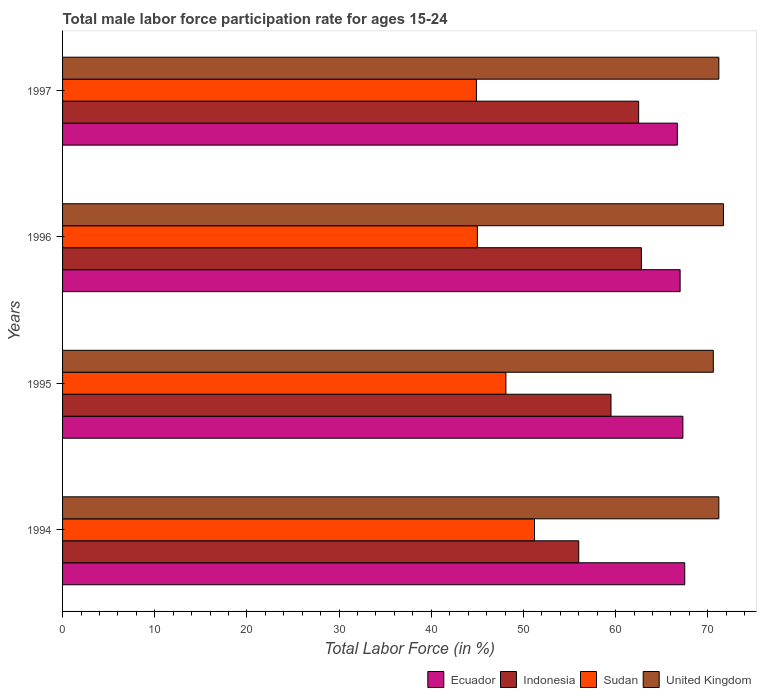Are the number of bars per tick equal to the number of legend labels?
Give a very brief answer. Yes. Are the number of bars on each tick of the Y-axis equal?
Your response must be concise. Yes. What is the male labor force participation rate in United Kingdom in 1994?
Provide a short and direct response. 71.2. Across all years, what is the maximum male labor force participation rate in Ecuador?
Ensure brevity in your answer.  67.5. Across all years, what is the minimum male labor force participation rate in Sudan?
Ensure brevity in your answer.  44.9. What is the total male labor force participation rate in United Kingdom in the graph?
Ensure brevity in your answer.  284.7. What is the difference between the male labor force participation rate in United Kingdom in 1995 and that in 1997?
Make the answer very short. -0.6. What is the difference between the male labor force participation rate in Indonesia in 1994 and the male labor force participation rate in Sudan in 1995?
Offer a very short reply. 7.9. What is the average male labor force participation rate in Sudan per year?
Offer a very short reply. 47.3. In the year 1994, what is the difference between the male labor force participation rate in United Kingdom and male labor force participation rate in Sudan?
Make the answer very short. 20. What is the ratio of the male labor force participation rate in Indonesia in 1994 to that in 1997?
Your answer should be very brief. 0.9. Is the male labor force participation rate in Ecuador in 1995 less than that in 1996?
Provide a short and direct response. No. What is the difference between the highest and the second highest male labor force participation rate in Indonesia?
Offer a terse response. 0.3. What is the difference between the highest and the lowest male labor force participation rate in Ecuador?
Keep it short and to the point. 0.8. Is it the case that in every year, the sum of the male labor force participation rate in United Kingdom and male labor force participation rate in Ecuador is greater than the sum of male labor force participation rate in Sudan and male labor force participation rate in Indonesia?
Offer a very short reply. Yes. What does the 3rd bar from the top in 1997 represents?
Provide a short and direct response. Indonesia. What does the 1st bar from the bottom in 1996 represents?
Your answer should be compact. Ecuador. How many bars are there?
Your answer should be very brief. 16. Are the values on the major ticks of X-axis written in scientific E-notation?
Give a very brief answer. No. Does the graph contain any zero values?
Keep it short and to the point. No. Where does the legend appear in the graph?
Provide a short and direct response. Bottom right. How many legend labels are there?
Your answer should be very brief. 4. What is the title of the graph?
Make the answer very short. Total male labor force participation rate for ages 15-24. What is the label or title of the X-axis?
Offer a terse response. Total Labor Force (in %). What is the label or title of the Y-axis?
Ensure brevity in your answer.  Years. What is the Total Labor Force (in %) in Ecuador in 1994?
Give a very brief answer. 67.5. What is the Total Labor Force (in %) in Indonesia in 1994?
Your response must be concise. 56. What is the Total Labor Force (in %) in Sudan in 1994?
Give a very brief answer. 51.2. What is the Total Labor Force (in %) in United Kingdom in 1994?
Offer a terse response. 71.2. What is the Total Labor Force (in %) in Ecuador in 1995?
Offer a very short reply. 67.3. What is the Total Labor Force (in %) of Indonesia in 1995?
Ensure brevity in your answer.  59.5. What is the Total Labor Force (in %) in Sudan in 1995?
Your answer should be compact. 48.1. What is the Total Labor Force (in %) in United Kingdom in 1995?
Keep it short and to the point. 70.6. What is the Total Labor Force (in %) of Indonesia in 1996?
Your response must be concise. 62.8. What is the Total Labor Force (in %) of Sudan in 1996?
Your answer should be compact. 45. What is the Total Labor Force (in %) of United Kingdom in 1996?
Your answer should be very brief. 71.7. What is the Total Labor Force (in %) in Ecuador in 1997?
Make the answer very short. 66.7. What is the Total Labor Force (in %) of Indonesia in 1997?
Make the answer very short. 62.5. What is the Total Labor Force (in %) in Sudan in 1997?
Offer a terse response. 44.9. What is the Total Labor Force (in %) of United Kingdom in 1997?
Provide a succinct answer. 71.2. Across all years, what is the maximum Total Labor Force (in %) of Ecuador?
Offer a terse response. 67.5. Across all years, what is the maximum Total Labor Force (in %) in Indonesia?
Ensure brevity in your answer.  62.8. Across all years, what is the maximum Total Labor Force (in %) in Sudan?
Keep it short and to the point. 51.2. Across all years, what is the maximum Total Labor Force (in %) in United Kingdom?
Provide a succinct answer. 71.7. Across all years, what is the minimum Total Labor Force (in %) of Ecuador?
Give a very brief answer. 66.7. Across all years, what is the minimum Total Labor Force (in %) of Indonesia?
Your response must be concise. 56. Across all years, what is the minimum Total Labor Force (in %) in Sudan?
Provide a succinct answer. 44.9. Across all years, what is the minimum Total Labor Force (in %) of United Kingdom?
Your answer should be compact. 70.6. What is the total Total Labor Force (in %) of Ecuador in the graph?
Your answer should be very brief. 268.5. What is the total Total Labor Force (in %) of Indonesia in the graph?
Give a very brief answer. 240.8. What is the total Total Labor Force (in %) in Sudan in the graph?
Give a very brief answer. 189.2. What is the total Total Labor Force (in %) of United Kingdom in the graph?
Your answer should be compact. 284.7. What is the difference between the Total Labor Force (in %) of Ecuador in 1994 and that in 1995?
Keep it short and to the point. 0.2. What is the difference between the Total Labor Force (in %) in United Kingdom in 1994 and that in 1995?
Your answer should be very brief. 0.6. What is the difference between the Total Labor Force (in %) in Ecuador in 1994 and that in 1996?
Keep it short and to the point. 0.5. What is the difference between the Total Labor Force (in %) in Ecuador in 1994 and that in 1997?
Your answer should be very brief. 0.8. What is the difference between the Total Labor Force (in %) of United Kingdom in 1994 and that in 1997?
Give a very brief answer. 0. What is the difference between the Total Labor Force (in %) of United Kingdom in 1995 and that in 1996?
Give a very brief answer. -1.1. What is the difference between the Total Labor Force (in %) in Sudan in 1995 and that in 1997?
Your answer should be very brief. 3.2. What is the difference between the Total Labor Force (in %) in United Kingdom in 1995 and that in 1997?
Provide a succinct answer. -0.6. What is the difference between the Total Labor Force (in %) in Ecuador in 1996 and that in 1997?
Provide a short and direct response. 0.3. What is the difference between the Total Labor Force (in %) of Indonesia in 1996 and that in 1997?
Ensure brevity in your answer.  0.3. What is the difference between the Total Labor Force (in %) in Sudan in 1996 and that in 1997?
Provide a short and direct response. 0.1. What is the difference between the Total Labor Force (in %) in United Kingdom in 1996 and that in 1997?
Provide a succinct answer. 0.5. What is the difference between the Total Labor Force (in %) in Ecuador in 1994 and the Total Labor Force (in %) in Indonesia in 1995?
Provide a succinct answer. 8. What is the difference between the Total Labor Force (in %) of Indonesia in 1994 and the Total Labor Force (in %) of United Kingdom in 1995?
Ensure brevity in your answer.  -14.6. What is the difference between the Total Labor Force (in %) in Sudan in 1994 and the Total Labor Force (in %) in United Kingdom in 1995?
Ensure brevity in your answer.  -19.4. What is the difference between the Total Labor Force (in %) of Ecuador in 1994 and the Total Labor Force (in %) of Indonesia in 1996?
Provide a short and direct response. 4.7. What is the difference between the Total Labor Force (in %) in Ecuador in 1994 and the Total Labor Force (in %) in Sudan in 1996?
Keep it short and to the point. 22.5. What is the difference between the Total Labor Force (in %) in Indonesia in 1994 and the Total Labor Force (in %) in United Kingdom in 1996?
Ensure brevity in your answer.  -15.7. What is the difference between the Total Labor Force (in %) in Sudan in 1994 and the Total Labor Force (in %) in United Kingdom in 1996?
Make the answer very short. -20.5. What is the difference between the Total Labor Force (in %) in Ecuador in 1994 and the Total Labor Force (in %) in Indonesia in 1997?
Offer a very short reply. 5. What is the difference between the Total Labor Force (in %) of Ecuador in 1994 and the Total Labor Force (in %) of Sudan in 1997?
Ensure brevity in your answer.  22.6. What is the difference between the Total Labor Force (in %) in Ecuador in 1994 and the Total Labor Force (in %) in United Kingdom in 1997?
Your answer should be compact. -3.7. What is the difference between the Total Labor Force (in %) of Indonesia in 1994 and the Total Labor Force (in %) of United Kingdom in 1997?
Your answer should be very brief. -15.2. What is the difference between the Total Labor Force (in %) of Ecuador in 1995 and the Total Labor Force (in %) of Indonesia in 1996?
Your answer should be compact. 4.5. What is the difference between the Total Labor Force (in %) in Ecuador in 1995 and the Total Labor Force (in %) in Sudan in 1996?
Provide a succinct answer. 22.3. What is the difference between the Total Labor Force (in %) in Ecuador in 1995 and the Total Labor Force (in %) in United Kingdom in 1996?
Give a very brief answer. -4.4. What is the difference between the Total Labor Force (in %) in Indonesia in 1995 and the Total Labor Force (in %) in Sudan in 1996?
Your response must be concise. 14.5. What is the difference between the Total Labor Force (in %) in Indonesia in 1995 and the Total Labor Force (in %) in United Kingdom in 1996?
Your response must be concise. -12.2. What is the difference between the Total Labor Force (in %) of Sudan in 1995 and the Total Labor Force (in %) of United Kingdom in 1996?
Offer a very short reply. -23.6. What is the difference between the Total Labor Force (in %) in Ecuador in 1995 and the Total Labor Force (in %) in Indonesia in 1997?
Provide a succinct answer. 4.8. What is the difference between the Total Labor Force (in %) of Ecuador in 1995 and the Total Labor Force (in %) of Sudan in 1997?
Your answer should be very brief. 22.4. What is the difference between the Total Labor Force (in %) in Ecuador in 1995 and the Total Labor Force (in %) in United Kingdom in 1997?
Give a very brief answer. -3.9. What is the difference between the Total Labor Force (in %) of Indonesia in 1995 and the Total Labor Force (in %) of Sudan in 1997?
Make the answer very short. 14.6. What is the difference between the Total Labor Force (in %) in Indonesia in 1995 and the Total Labor Force (in %) in United Kingdom in 1997?
Your answer should be compact. -11.7. What is the difference between the Total Labor Force (in %) in Sudan in 1995 and the Total Labor Force (in %) in United Kingdom in 1997?
Provide a succinct answer. -23.1. What is the difference between the Total Labor Force (in %) in Ecuador in 1996 and the Total Labor Force (in %) in Indonesia in 1997?
Provide a succinct answer. 4.5. What is the difference between the Total Labor Force (in %) in Ecuador in 1996 and the Total Labor Force (in %) in Sudan in 1997?
Make the answer very short. 22.1. What is the difference between the Total Labor Force (in %) of Indonesia in 1996 and the Total Labor Force (in %) of Sudan in 1997?
Your response must be concise. 17.9. What is the difference between the Total Labor Force (in %) of Sudan in 1996 and the Total Labor Force (in %) of United Kingdom in 1997?
Offer a very short reply. -26.2. What is the average Total Labor Force (in %) of Ecuador per year?
Ensure brevity in your answer.  67.12. What is the average Total Labor Force (in %) of Indonesia per year?
Your answer should be very brief. 60.2. What is the average Total Labor Force (in %) in Sudan per year?
Provide a succinct answer. 47.3. What is the average Total Labor Force (in %) in United Kingdom per year?
Give a very brief answer. 71.17. In the year 1994, what is the difference between the Total Labor Force (in %) in Ecuador and Total Labor Force (in %) in Sudan?
Provide a succinct answer. 16.3. In the year 1994, what is the difference between the Total Labor Force (in %) in Indonesia and Total Labor Force (in %) in Sudan?
Your answer should be very brief. 4.8. In the year 1994, what is the difference between the Total Labor Force (in %) in Indonesia and Total Labor Force (in %) in United Kingdom?
Provide a short and direct response. -15.2. In the year 1995, what is the difference between the Total Labor Force (in %) of Ecuador and Total Labor Force (in %) of Indonesia?
Your answer should be very brief. 7.8. In the year 1995, what is the difference between the Total Labor Force (in %) of Indonesia and Total Labor Force (in %) of Sudan?
Your answer should be very brief. 11.4. In the year 1995, what is the difference between the Total Labor Force (in %) of Sudan and Total Labor Force (in %) of United Kingdom?
Give a very brief answer. -22.5. In the year 1996, what is the difference between the Total Labor Force (in %) of Ecuador and Total Labor Force (in %) of Indonesia?
Your answer should be very brief. 4.2. In the year 1996, what is the difference between the Total Labor Force (in %) in Indonesia and Total Labor Force (in %) in Sudan?
Offer a very short reply. 17.8. In the year 1996, what is the difference between the Total Labor Force (in %) in Sudan and Total Labor Force (in %) in United Kingdom?
Offer a terse response. -26.7. In the year 1997, what is the difference between the Total Labor Force (in %) in Ecuador and Total Labor Force (in %) in Sudan?
Provide a short and direct response. 21.8. In the year 1997, what is the difference between the Total Labor Force (in %) of Ecuador and Total Labor Force (in %) of United Kingdom?
Your answer should be compact. -4.5. In the year 1997, what is the difference between the Total Labor Force (in %) in Indonesia and Total Labor Force (in %) in United Kingdom?
Make the answer very short. -8.7. In the year 1997, what is the difference between the Total Labor Force (in %) in Sudan and Total Labor Force (in %) in United Kingdom?
Your response must be concise. -26.3. What is the ratio of the Total Labor Force (in %) in Sudan in 1994 to that in 1995?
Keep it short and to the point. 1.06. What is the ratio of the Total Labor Force (in %) in United Kingdom in 1994 to that in 1995?
Provide a succinct answer. 1.01. What is the ratio of the Total Labor Force (in %) of Ecuador in 1994 to that in 1996?
Offer a terse response. 1.01. What is the ratio of the Total Labor Force (in %) in Indonesia in 1994 to that in 1996?
Give a very brief answer. 0.89. What is the ratio of the Total Labor Force (in %) of Sudan in 1994 to that in 1996?
Provide a short and direct response. 1.14. What is the ratio of the Total Labor Force (in %) of United Kingdom in 1994 to that in 1996?
Your answer should be very brief. 0.99. What is the ratio of the Total Labor Force (in %) of Ecuador in 1994 to that in 1997?
Offer a very short reply. 1.01. What is the ratio of the Total Labor Force (in %) of Indonesia in 1994 to that in 1997?
Give a very brief answer. 0.9. What is the ratio of the Total Labor Force (in %) in Sudan in 1994 to that in 1997?
Make the answer very short. 1.14. What is the ratio of the Total Labor Force (in %) in United Kingdom in 1994 to that in 1997?
Keep it short and to the point. 1. What is the ratio of the Total Labor Force (in %) in Indonesia in 1995 to that in 1996?
Give a very brief answer. 0.95. What is the ratio of the Total Labor Force (in %) of Sudan in 1995 to that in 1996?
Ensure brevity in your answer.  1.07. What is the ratio of the Total Labor Force (in %) in United Kingdom in 1995 to that in 1996?
Ensure brevity in your answer.  0.98. What is the ratio of the Total Labor Force (in %) of Sudan in 1995 to that in 1997?
Your response must be concise. 1.07. What is the ratio of the Total Labor Force (in %) in United Kingdom in 1995 to that in 1997?
Offer a terse response. 0.99. What is the ratio of the Total Labor Force (in %) in United Kingdom in 1996 to that in 1997?
Provide a succinct answer. 1.01. What is the difference between the highest and the second highest Total Labor Force (in %) of Indonesia?
Provide a succinct answer. 0.3. What is the difference between the highest and the second highest Total Labor Force (in %) of Sudan?
Make the answer very short. 3.1. What is the difference between the highest and the lowest Total Labor Force (in %) in Ecuador?
Offer a very short reply. 0.8. What is the difference between the highest and the lowest Total Labor Force (in %) of Sudan?
Keep it short and to the point. 6.3. What is the difference between the highest and the lowest Total Labor Force (in %) in United Kingdom?
Make the answer very short. 1.1. 